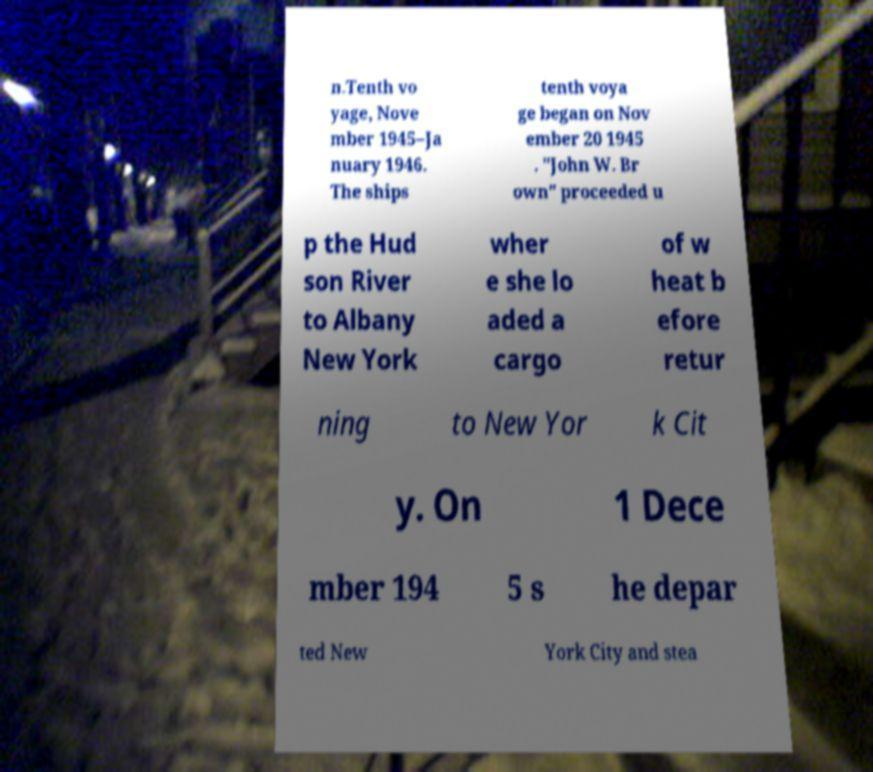Can you read and provide the text displayed in the image?This photo seems to have some interesting text. Can you extract and type it out for me? n.Tenth vo yage, Nove mber 1945–Ja nuary 1946. The ships tenth voya ge began on Nov ember 20 1945 . "John W. Br own" proceeded u p the Hud son River to Albany New York wher e she lo aded a cargo of w heat b efore retur ning to New Yor k Cit y. On 1 Dece mber 194 5 s he depar ted New York City and stea 